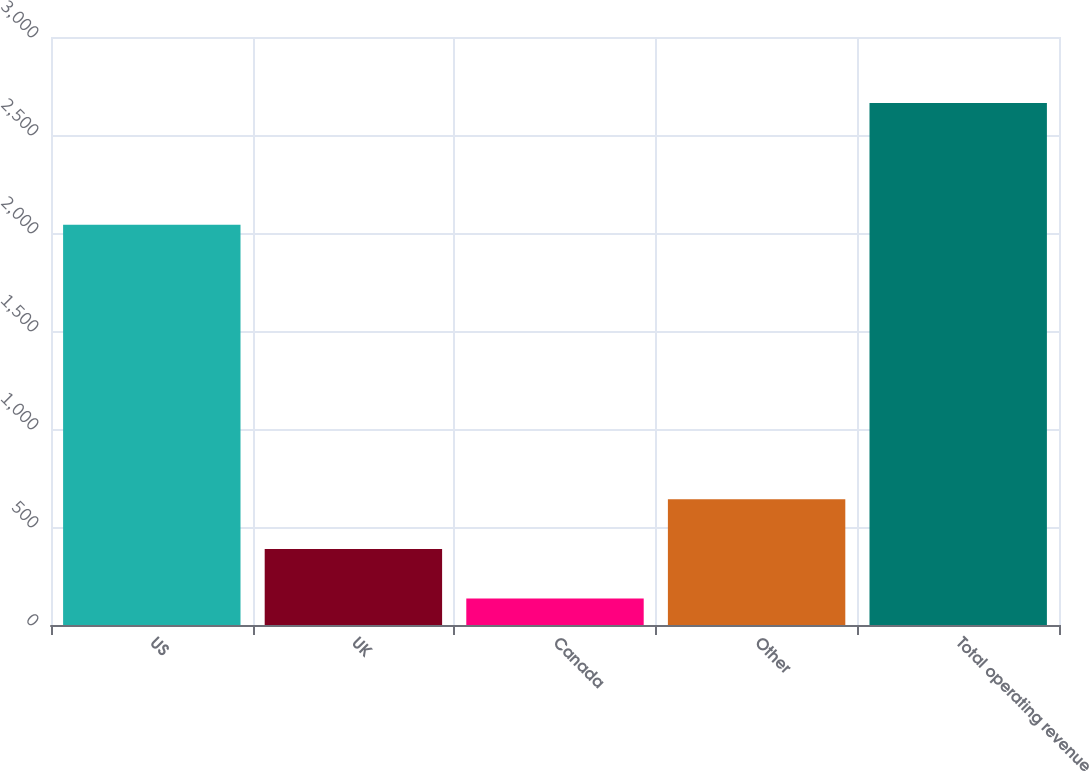Convert chart. <chart><loc_0><loc_0><loc_500><loc_500><bar_chart><fcel>US<fcel>UK<fcel>Canada<fcel>Other<fcel>Total operating revenue<nl><fcel>2041.7<fcel>388.31<fcel>135.5<fcel>641.12<fcel>2663.6<nl></chart> 